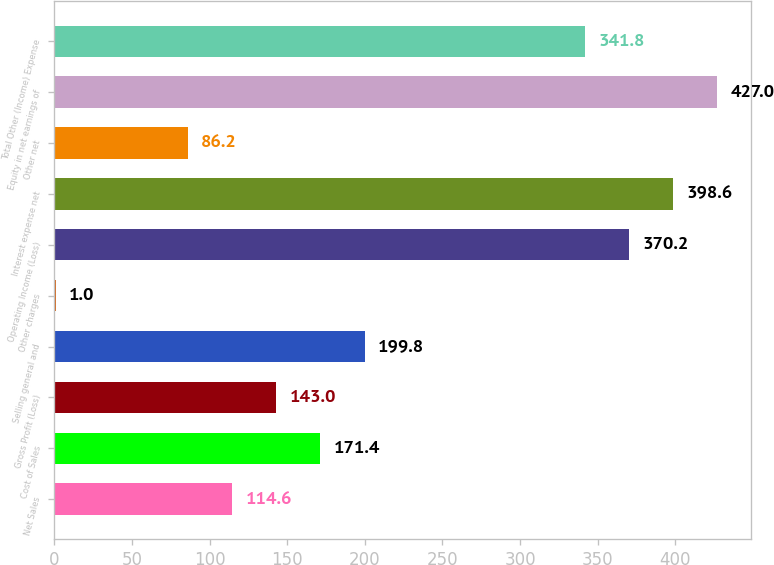Convert chart to OTSL. <chart><loc_0><loc_0><loc_500><loc_500><bar_chart><fcel>Net Sales<fcel>Cost of Sales<fcel>Gross Profit (Loss)<fcel>Selling general and<fcel>Other charges<fcel>Operating Income (Loss)<fcel>Interest expense net<fcel>Other net<fcel>Equity in net earnings of<fcel>Total Other (Income) Expense<nl><fcel>114.6<fcel>171.4<fcel>143<fcel>199.8<fcel>1<fcel>370.2<fcel>398.6<fcel>86.2<fcel>427<fcel>341.8<nl></chart> 